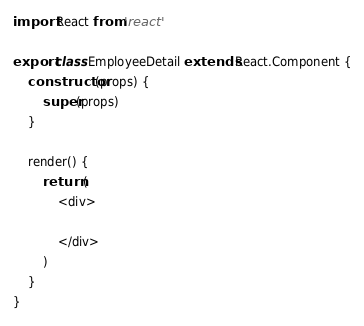<code> <loc_0><loc_0><loc_500><loc_500><_JavaScript_>import React from 'react'

export class EmployeeDetail extends React.Component {
    constructor(props) {
        super(props)
    }

    render() {
        return (
            <div>

            </div>
        )
    }
}</code> 